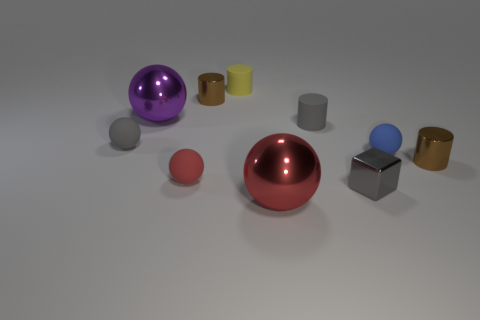The ball that is both behind the big red object and to the right of the yellow thing is what color?
Ensure brevity in your answer.  Blue. Is the color of the rubber cylinder that is right of the large red object the same as the metallic cube?
Your answer should be compact. Yes. The red rubber thing that is the same size as the gray metal cube is what shape?
Offer a very short reply. Sphere. How many other objects are the same color as the metallic block?
Your answer should be very brief. 2. Do the cube and the brown shiny cylinder that is right of the blue matte object have the same size?
Make the answer very short. Yes. What is the color of the cube?
Ensure brevity in your answer.  Gray. The gray object in front of the gray rubber object that is on the left side of the brown metal object to the left of the small gray cube is what shape?
Your answer should be compact. Cube. The large object that is on the left side of the small metallic cylinder behind the gray ball is made of what material?
Your response must be concise. Metal. There is a small yellow thing that is made of the same material as the tiny red sphere; what shape is it?
Give a very brief answer. Cylinder. Is there anything else that has the same shape as the small gray metal thing?
Offer a very short reply. No. 